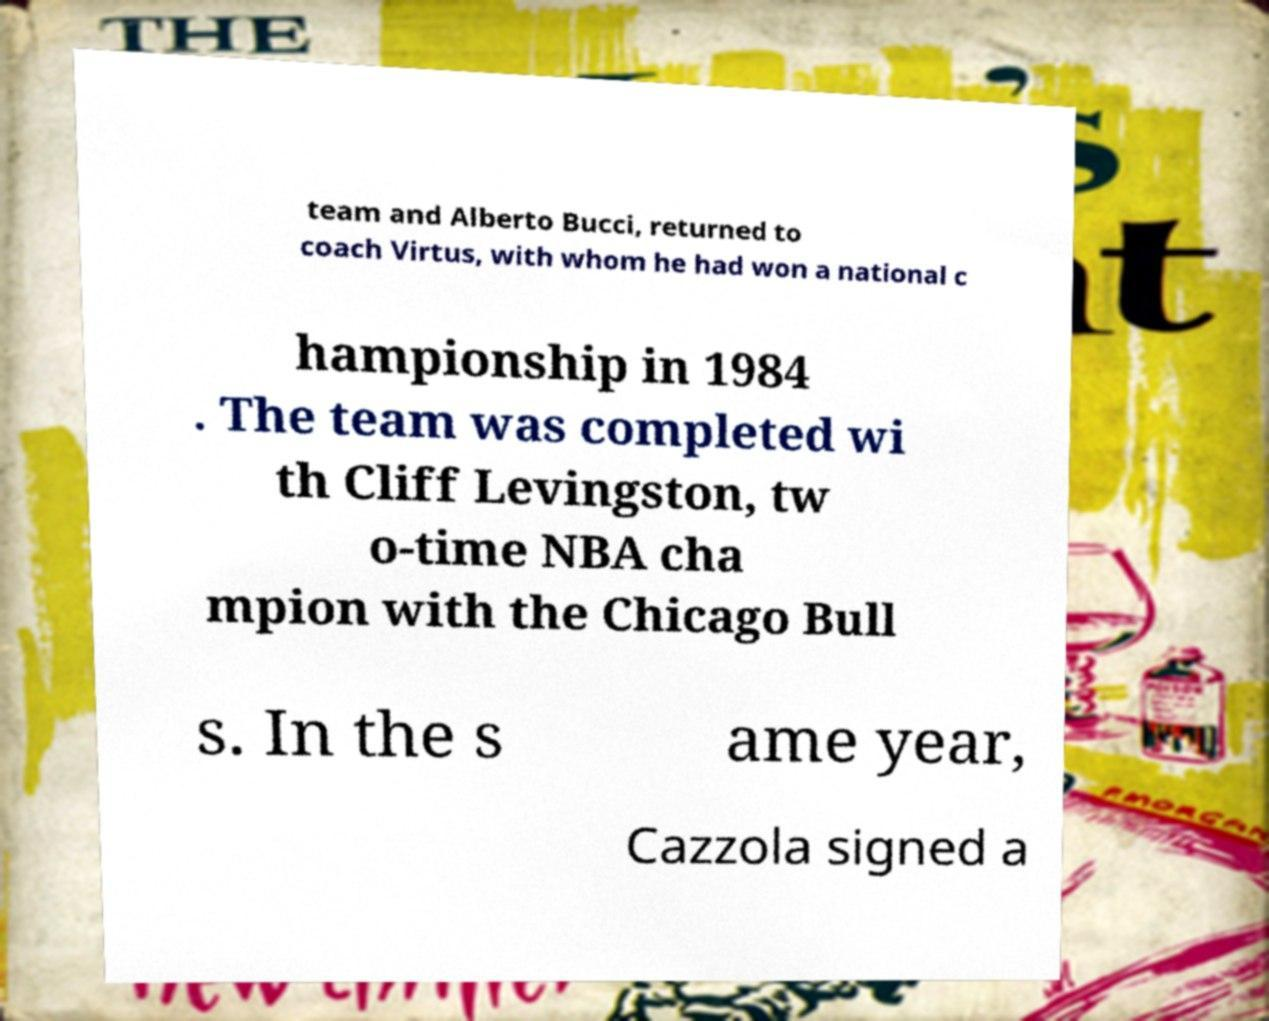There's text embedded in this image that I need extracted. Can you transcribe it verbatim? team and Alberto Bucci, returned to coach Virtus, with whom he had won a national c hampionship in 1984 . The team was completed wi th Cliff Levingston, tw o-time NBA cha mpion with the Chicago Bull s. In the s ame year, Cazzola signed a 